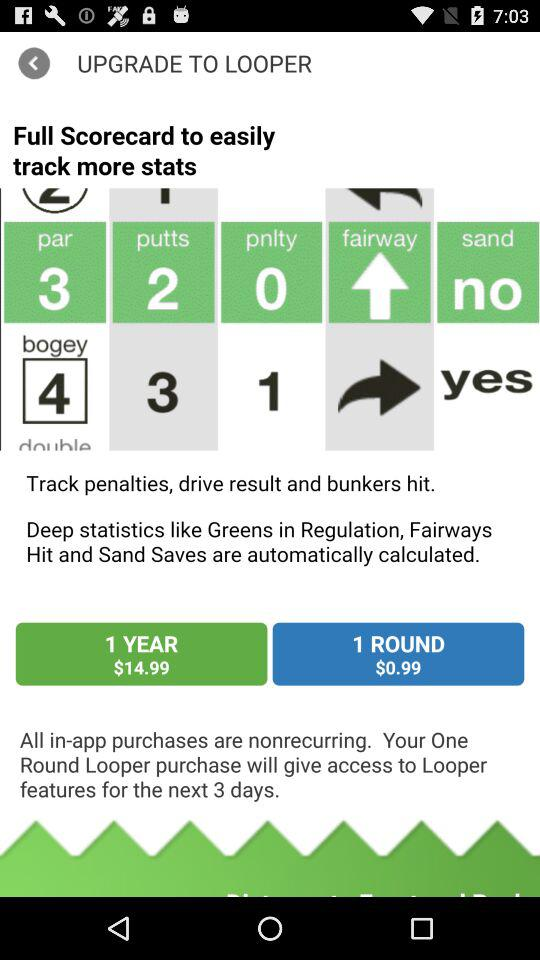What are the charges for 1 year? The charges for 1 year are $14.99. 